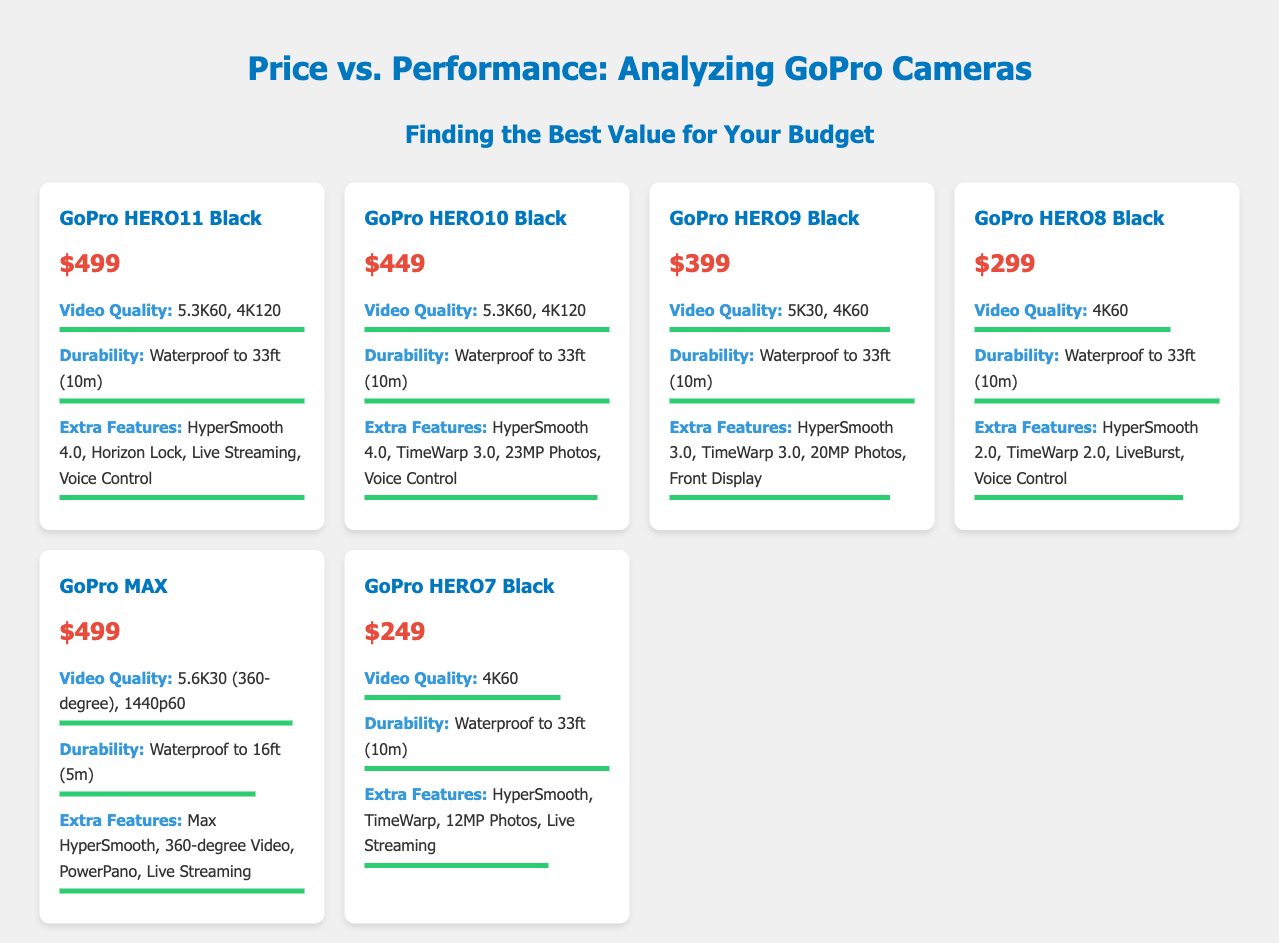what is the price of GoPro HERO11 Black? The price of GoPro HERO11 Black is listed in the document as $499.
Answer: $499 what is the video quality of GoPro HERO9 Black? The video quality of GoPro HERO9 Black is specified as 5K30, 4K60 in the document.
Answer: 5K30, 4K60 which GoPro model has the highest price? The prices of the models indicate that the GoPro HERO11 Black and GoPro MAX both have the highest price at $499.
Answer: GoPro HERO11 Black and GoPro MAX how many GoPro models are waterproof to 33ft? The document mentions that four models have durability waterproof to 33ft (10m).
Answer: 4 what is the extra feature of GoPro HERO8 Black? The document lists the extra features of GoPro HERO8 Black as HyperSmooth 2.0, TimeWarp 2.0, LiveBurst, and Voice Control.
Answer: HyperSmooth 2.0, TimeWarp 2.0, LiveBurst, Voice Control which GoPro model has the lowest price? Based on the prices listed, the GoPro HERO7 Black has the lowest price at $249.
Answer: GoPro HERO7 Black what is the durability feature of the GoPro MAX? The durability feature of the GoPro MAX is specified as waterproof to 16ft (5m).
Answer: Waterproof to 16ft (5m) which model has the same video quality as GoPro HERO10 Black? The GoPro HERO11 Black has the same video quality as GoPro HERO10 Black, which is 5.3K60, 4K120.
Answer: GoPro HERO11 Black 